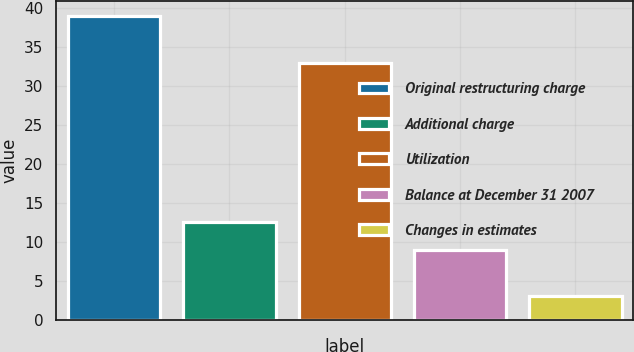Convert chart to OTSL. <chart><loc_0><loc_0><loc_500><loc_500><bar_chart><fcel>Original restructuring charge<fcel>Additional charge<fcel>Utilization<fcel>Balance at December 31 2007<fcel>Changes in estimates<nl><fcel>39<fcel>12.6<fcel>33<fcel>9<fcel>3<nl></chart> 